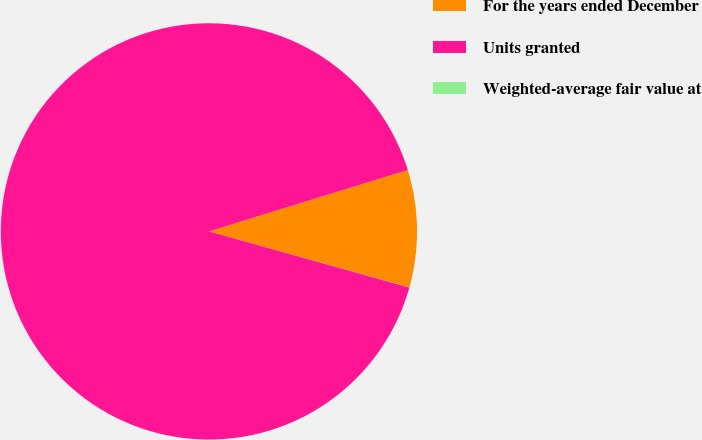<chart> <loc_0><loc_0><loc_500><loc_500><pie_chart><fcel>For the years ended December<fcel>Units granted<fcel>Weighted-average fair value at<nl><fcel>9.1%<fcel>90.89%<fcel>0.01%<nl></chart> 